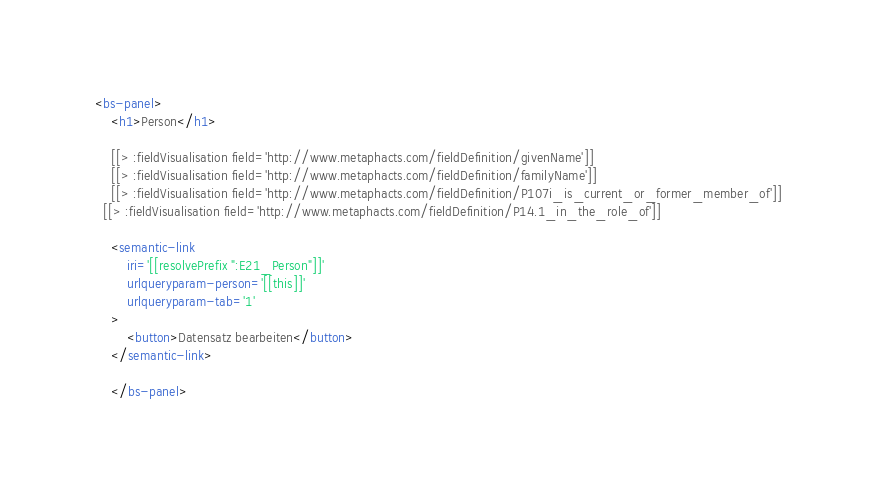Convert code to text. <code><loc_0><loc_0><loc_500><loc_500><_HTML_><bs-panel>
    <h1>Person</h1>

    [[> :fieldVisualisation field='http://www.metaphacts.com/fieldDefinition/givenName']]
    [[> :fieldVisualisation field='http://www.metaphacts.com/fieldDefinition/familyName']]
    [[> :fieldVisualisation field='http://www.metaphacts.com/fieldDefinition/P107i_is_current_or_former_member_of']]
  [[> :fieldVisualisation field='http://www.metaphacts.com/fieldDefinition/P14.1_in_the_role_of']]
 
    <semantic-link
        iri='[[resolvePrefix ":E21_Person"]]'
        urlqueryparam-person='[[this]]'
        urlqueryparam-tab='1'
    >
        <button>Datensatz bearbeiten</button>
    </semantic-link>
  
    </bs-panel></code> 